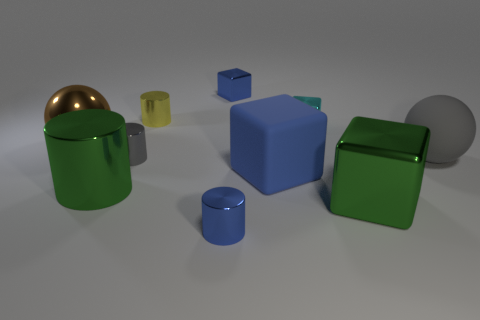How do the objects seem to be arranged in terms of proximity and size? The objects are arranged with a fairly even distribution throughout the space, displaying a mix of sizes. The larger objects, like the big blue cube and the large green cylinder, take up more space and are more prominent in the foreground. The smaller objects, such as the small cubes and cylinders, are scattered around, with some closer to the camera and others further away. The gray sphere is positioned towards the front, slightly off-center. 